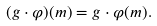Convert formula to latex. <formula><loc_0><loc_0><loc_500><loc_500>( g \cdot \varphi ) ( m ) = g \cdot \varphi ( m ) .</formula> 